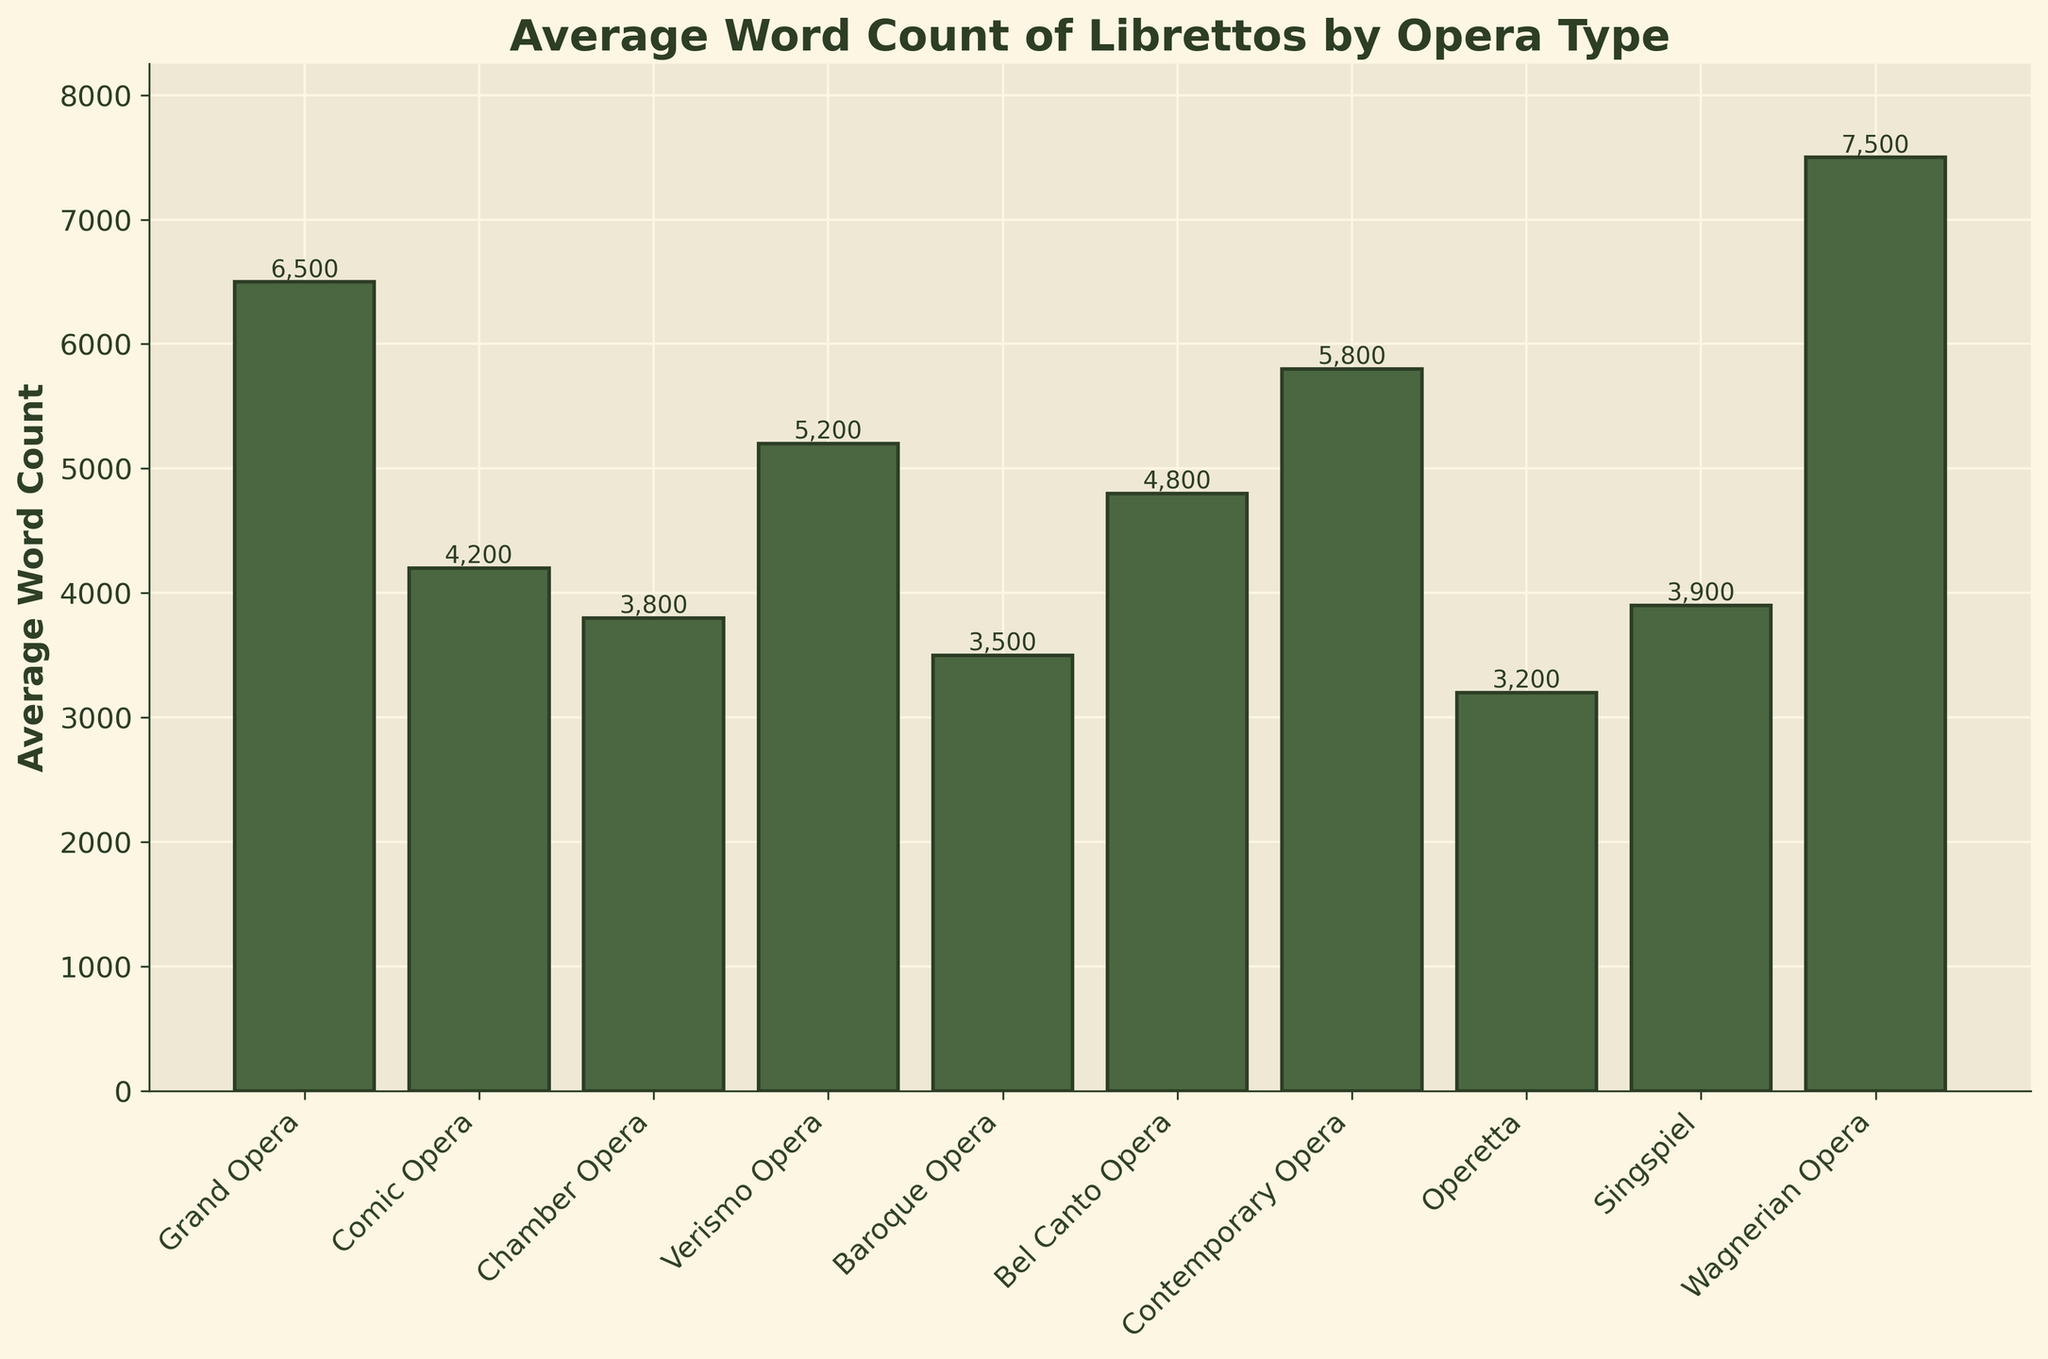Which opera type has the highest average word count? The bar with the highest value should be examined. Here, Wagnerian Opera has the highest bar.
Answer: Wagnerian Opera What is the difference in average word count between Grand Opera and Comic Opera? Subtract the average word count of Comic Opera (4200) from that of Grand Opera (6500). This gives 6500 - 4200.
Answer: 2300 Which types of opera have an average word count greater than 5000? Check the bars that surpass the 5000 mark. Wagnerian Opera, Grand Opera, Verismo Opera, and Contemporary Opera have heights greater than 5000.
Answer: Wagnerian Opera, Grand Opera, Verismo Opera, Contemporary Opera What are the two opera types with the lowest average word counts? Identify the two shortest bars on the chart. Operetta and Baroque Opera have the lowest bars.
Answer: Operetta, Baroque Opera How much higher is the word count of Contemporary Opera compared to Chamber Opera? Subtract the average word count of Chamber Opera (3800) from that of Contemporary Opera (5800). This gives 5800 - 3800.
Answer: 2000 What is the average word count of Bel Canto Opera? Find the height of the bar corresponding to Bel Canto Opera. It is 4800.
Answer: 4800 What is the difference between the highest and lowest average word counts? Subtract the smallest average word count (Operetta, 3200) from the largest (Wagnerian Opera, 7500). This gives 7500 - 3200.
Answer: 4300 Which opera types have an average word count between 4000 and 5000, inclusive? Look for bars that are within the range from 4000 to 5000. Comic Opera, Bel Canto Opera, and Verismo Opera are within this range.
Answer: Comic Opera, Bel Canto Opera, Verismo Opera Compare the average word count of Singspiel to that of Chamber Opera. Which one is higher? Compare the heights of the corresponding bars. The Singspiel bar (3900) is slightly higher than the Chamber Opera bar (3800).
Answer: Singspiel 